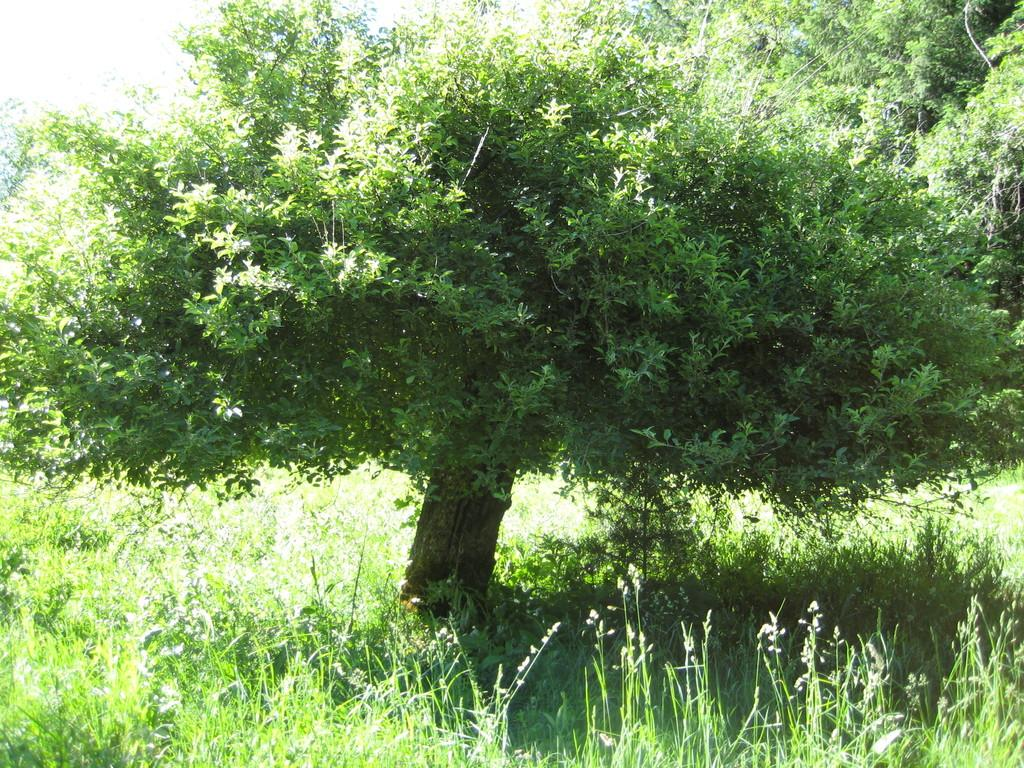What type of vegetation can be seen in the image? There are trees and plants in the image. Can you describe the plants in the image? The plants in the image are not specified, but they are present alongside the trees. How many fingers can be seen holding the plants in the image? There are no fingers visible in the image, as it only features trees and plants. What type of adhesive is being used to attach the plants to the trees in the image? There is no adhesive or any indication of attaching plants to trees in the image. 